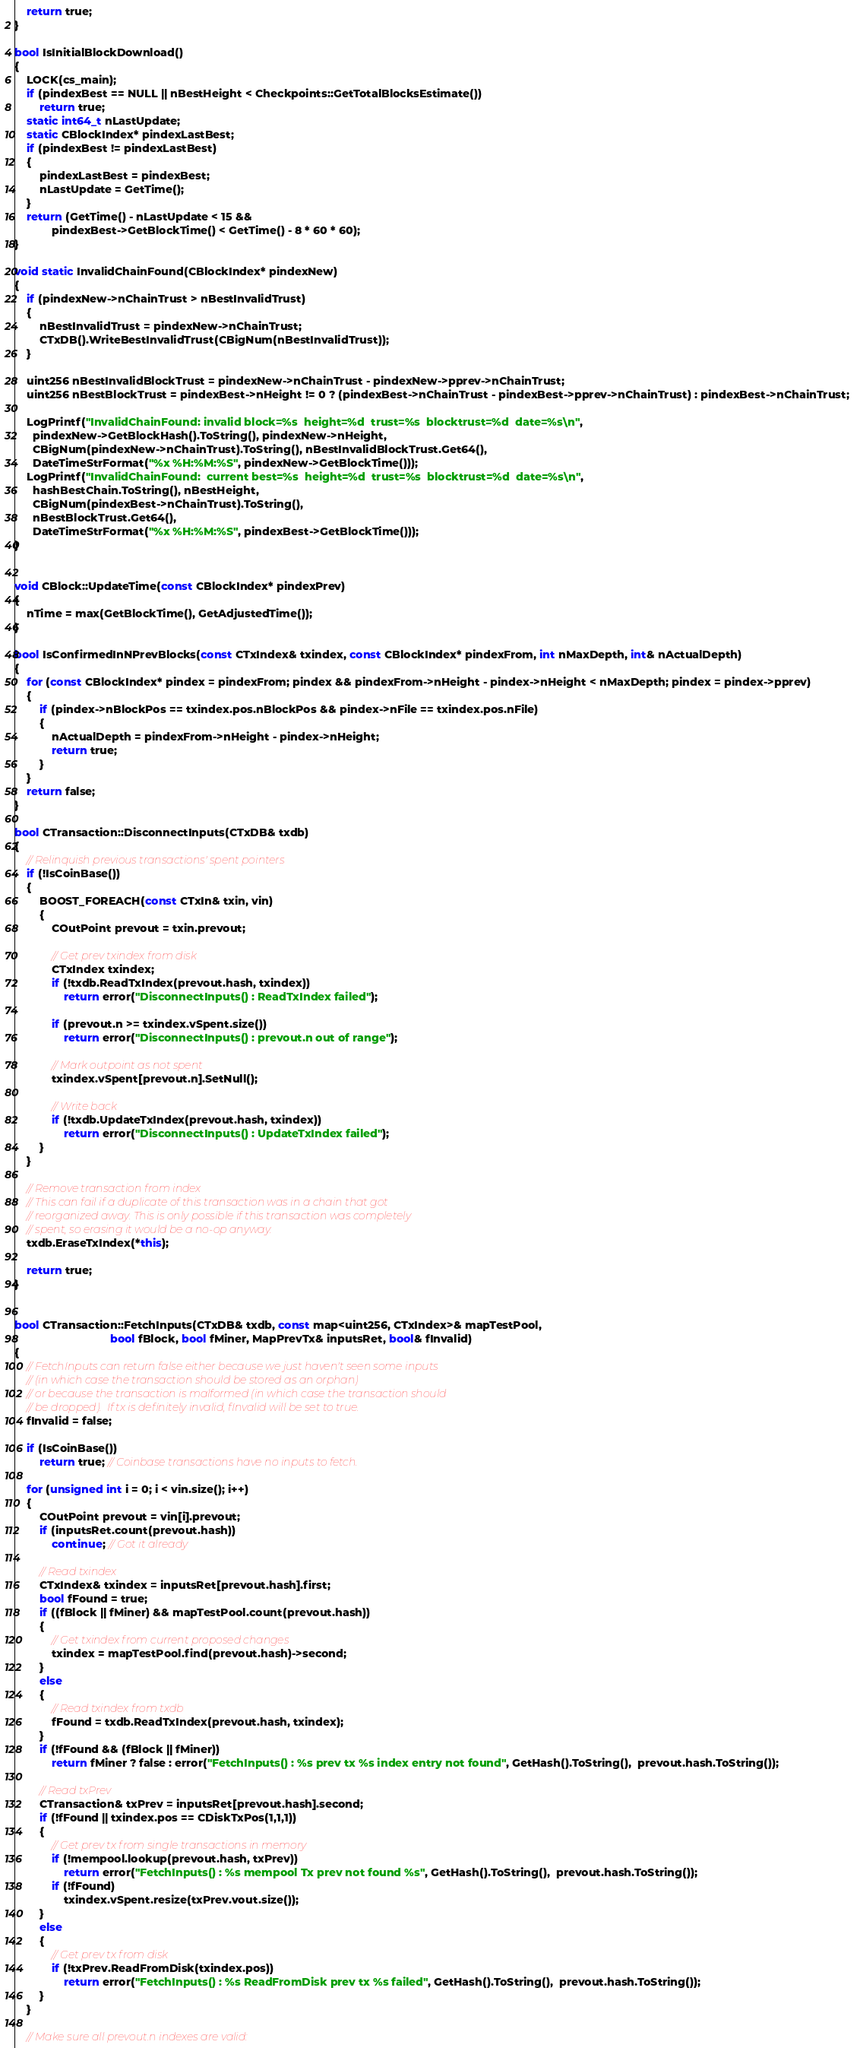Convert code to text. <code><loc_0><loc_0><loc_500><loc_500><_C++_>
    return true;
}

bool IsInitialBlockDownload()
{
    LOCK(cs_main);
    if (pindexBest == NULL || nBestHeight < Checkpoints::GetTotalBlocksEstimate())
        return true;
    static int64_t nLastUpdate;
    static CBlockIndex* pindexLastBest;
    if (pindexBest != pindexLastBest)
    {
        pindexLastBest = pindexBest;
        nLastUpdate = GetTime();
    }
    return (GetTime() - nLastUpdate < 15 &&
            pindexBest->GetBlockTime() < GetTime() - 8 * 60 * 60);
}

void static InvalidChainFound(CBlockIndex* pindexNew)
{
    if (pindexNew->nChainTrust > nBestInvalidTrust)
    {
        nBestInvalidTrust = pindexNew->nChainTrust;
        CTxDB().WriteBestInvalidTrust(CBigNum(nBestInvalidTrust));
    }

    uint256 nBestInvalidBlockTrust = pindexNew->nChainTrust - pindexNew->pprev->nChainTrust;
    uint256 nBestBlockTrust = pindexBest->nHeight != 0 ? (pindexBest->nChainTrust - pindexBest->pprev->nChainTrust) : pindexBest->nChainTrust;

    LogPrintf("InvalidChainFound: invalid block=%s  height=%d  trust=%s  blocktrust=%d  date=%s\n",
      pindexNew->GetBlockHash().ToString(), pindexNew->nHeight,
      CBigNum(pindexNew->nChainTrust).ToString(), nBestInvalidBlockTrust.Get64(),
      DateTimeStrFormat("%x %H:%M:%S", pindexNew->GetBlockTime()));
    LogPrintf("InvalidChainFound:  current best=%s  height=%d  trust=%s  blocktrust=%d  date=%s\n",
      hashBestChain.ToString(), nBestHeight,
      CBigNum(pindexBest->nChainTrust).ToString(),
      nBestBlockTrust.Get64(),
      DateTimeStrFormat("%x %H:%M:%S", pindexBest->GetBlockTime()));
}


void CBlock::UpdateTime(const CBlockIndex* pindexPrev)
{
    nTime = max(GetBlockTime(), GetAdjustedTime());
}

bool IsConfirmedInNPrevBlocks(const CTxIndex& txindex, const CBlockIndex* pindexFrom, int nMaxDepth, int& nActualDepth)
{
    for (const CBlockIndex* pindex = pindexFrom; pindex && pindexFrom->nHeight - pindex->nHeight < nMaxDepth; pindex = pindex->pprev)
    {
        if (pindex->nBlockPos == txindex.pos.nBlockPos && pindex->nFile == txindex.pos.nFile)
        {
            nActualDepth = pindexFrom->nHeight - pindex->nHeight;
            return true;
        }
    }
    return false;
}

bool CTransaction::DisconnectInputs(CTxDB& txdb)
{
    // Relinquish previous transactions' spent pointers
    if (!IsCoinBase())
    {
        BOOST_FOREACH(const CTxIn& txin, vin)
        {
            COutPoint prevout = txin.prevout;

            // Get prev txindex from disk
            CTxIndex txindex;
            if (!txdb.ReadTxIndex(prevout.hash, txindex))
                return error("DisconnectInputs() : ReadTxIndex failed");

            if (prevout.n >= txindex.vSpent.size())
                return error("DisconnectInputs() : prevout.n out of range");

            // Mark outpoint as not spent
            txindex.vSpent[prevout.n].SetNull();

            // Write back
            if (!txdb.UpdateTxIndex(prevout.hash, txindex))
                return error("DisconnectInputs() : UpdateTxIndex failed");
        }
    }

    // Remove transaction from index
    // This can fail if a duplicate of this transaction was in a chain that got
    // reorganized away. This is only possible if this transaction was completely
    // spent, so erasing it would be a no-op anyway.
    txdb.EraseTxIndex(*this);

    return true;
}


bool CTransaction::FetchInputs(CTxDB& txdb, const map<uint256, CTxIndex>& mapTestPool,
                               bool fBlock, bool fMiner, MapPrevTx& inputsRet, bool& fInvalid)
{
    // FetchInputs can return false either because we just haven't seen some inputs
    // (in which case the transaction should be stored as an orphan)
    // or because the transaction is malformed (in which case the transaction should
    // be dropped).  If tx is definitely invalid, fInvalid will be set to true.
    fInvalid = false;

    if (IsCoinBase())
        return true; // Coinbase transactions have no inputs to fetch.

    for (unsigned int i = 0; i < vin.size(); i++)
    {
        COutPoint prevout = vin[i].prevout;
        if (inputsRet.count(prevout.hash))
            continue; // Got it already

        // Read txindex
        CTxIndex& txindex = inputsRet[prevout.hash].first;
        bool fFound = true;
        if ((fBlock || fMiner) && mapTestPool.count(prevout.hash))
        {
            // Get txindex from current proposed changes
            txindex = mapTestPool.find(prevout.hash)->second;
        }
        else
        {
            // Read txindex from txdb
            fFound = txdb.ReadTxIndex(prevout.hash, txindex);
        }
        if (!fFound && (fBlock || fMiner))
            return fMiner ? false : error("FetchInputs() : %s prev tx %s index entry not found", GetHash().ToString(),  prevout.hash.ToString());

        // Read txPrev
        CTransaction& txPrev = inputsRet[prevout.hash].second;
        if (!fFound || txindex.pos == CDiskTxPos(1,1,1))
        {
            // Get prev tx from single transactions in memory
            if (!mempool.lookup(prevout.hash, txPrev))
                return error("FetchInputs() : %s mempool Tx prev not found %s", GetHash().ToString(),  prevout.hash.ToString());
            if (!fFound)
                txindex.vSpent.resize(txPrev.vout.size());
        }
        else
        {
            // Get prev tx from disk
            if (!txPrev.ReadFromDisk(txindex.pos))
                return error("FetchInputs() : %s ReadFromDisk prev tx %s failed", GetHash().ToString(),  prevout.hash.ToString());
        }
    }

    // Make sure all prevout.n indexes are valid:</code> 